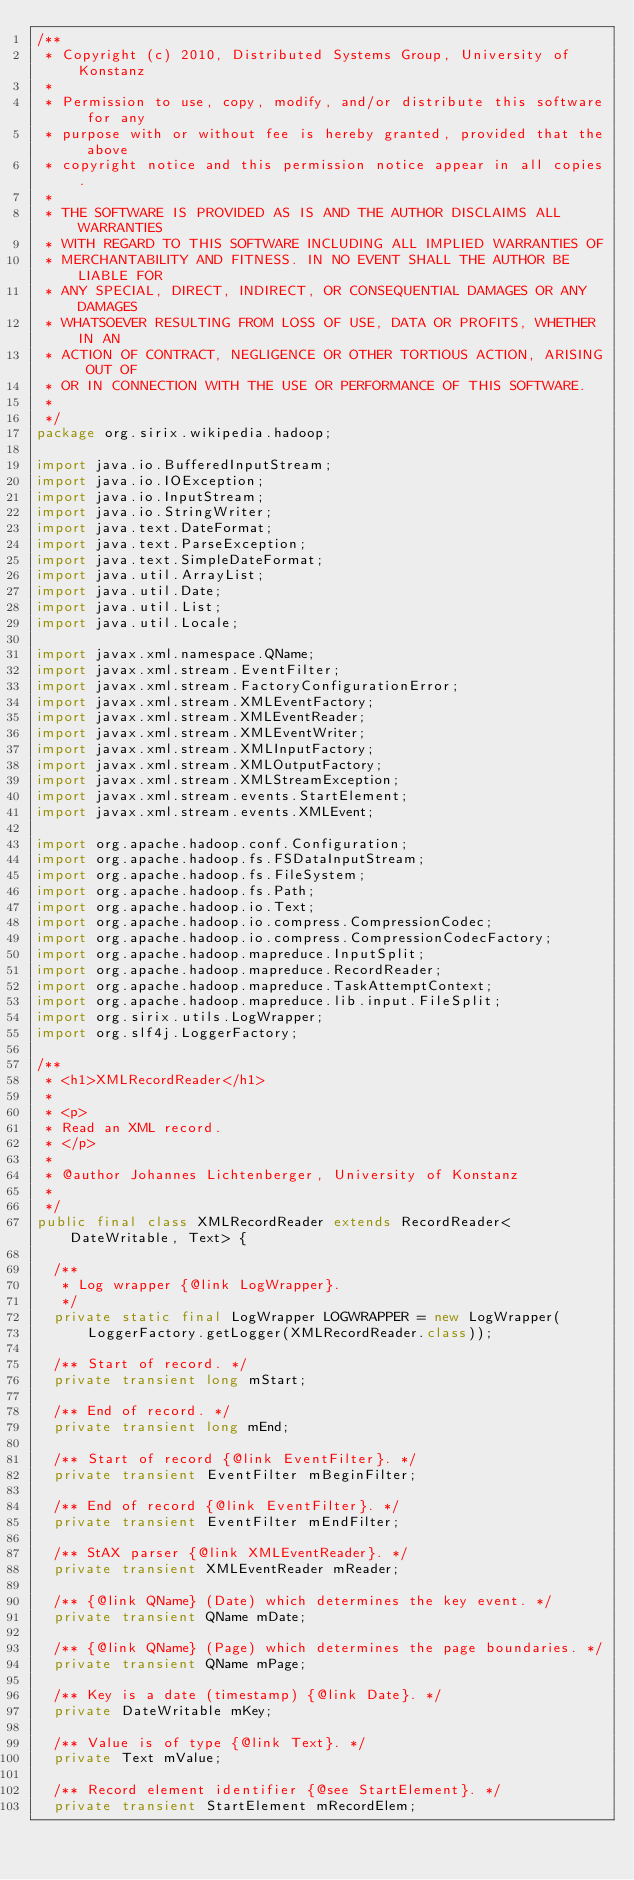<code> <loc_0><loc_0><loc_500><loc_500><_Java_>/**
 * Copyright (c) 2010, Distributed Systems Group, University of Konstanz
 * 
 * Permission to use, copy, modify, and/or distribute this software for any
 * purpose with or without fee is hereby granted, provided that the above
 * copyright notice and this permission notice appear in all copies.
 * 
 * THE SOFTWARE IS PROVIDED AS IS AND THE AUTHOR DISCLAIMS ALL WARRANTIES
 * WITH REGARD TO THIS SOFTWARE INCLUDING ALL IMPLIED WARRANTIES OF
 * MERCHANTABILITY AND FITNESS. IN NO EVENT SHALL THE AUTHOR BE LIABLE FOR
 * ANY SPECIAL, DIRECT, INDIRECT, OR CONSEQUENTIAL DAMAGES OR ANY DAMAGES
 * WHATSOEVER RESULTING FROM LOSS OF USE, DATA OR PROFITS, WHETHER IN AN
 * ACTION OF CONTRACT, NEGLIGENCE OR OTHER TORTIOUS ACTION, ARISING OUT OF
 * OR IN CONNECTION WITH THE USE OR PERFORMANCE OF THIS SOFTWARE.
 * 
 */
package org.sirix.wikipedia.hadoop;

import java.io.BufferedInputStream;
import java.io.IOException;
import java.io.InputStream;
import java.io.StringWriter;
import java.text.DateFormat;
import java.text.ParseException;
import java.text.SimpleDateFormat;
import java.util.ArrayList;
import java.util.Date;
import java.util.List;
import java.util.Locale;

import javax.xml.namespace.QName;
import javax.xml.stream.EventFilter;
import javax.xml.stream.FactoryConfigurationError;
import javax.xml.stream.XMLEventFactory;
import javax.xml.stream.XMLEventReader;
import javax.xml.stream.XMLEventWriter;
import javax.xml.stream.XMLInputFactory;
import javax.xml.stream.XMLOutputFactory;
import javax.xml.stream.XMLStreamException;
import javax.xml.stream.events.StartElement;
import javax.xml.stream.events.XMLEvent;

import org.apache.hadoop.conf.Configuration;
import org.apache.hadoop.fs.FSDataInputStream;
import org.apache.hadoop.fs.FileSystem;
import org.apache.hadoop.fs.Path;
import org.apache.hadoop.io.Text;
import org.apache.hadoop.io.compress.CompressionCodec;
import org.apache.hadoop.io.compress.CompressionCodecFactory;
import org.apache.hadoop.mapreduce.InputSplit;
import org.apache.hadoop.mapreduce.RecordReader;
import org.apache.hadoop.mapreduce.TaskAttemptContext;
import org.apache.hadoop.mapreduce.lib.input.FileSplit;
import org.sirix.utils.LogWrapper;
import org.slf4j.LoggerFactory;

/**
 * <h1>XMLRecordReader</h1>
 * 
 * <p>
 * Read an XML record.
 * </p>
 * 
 * @author Johannes Lichtenberger, University of Konstanz
 * 
 */
public final class XMLRecordReader extends RecordReader<DateWritable, Text> {

	/**
	 * Log wrapper {@link LogWrapper}.
	 */
	private static final LogWrapper LOGWRAPPER = new LogWrapper(
			LoggerFactory.getLogger(XMLRecordReader.class));

	/** Start of record. */
	private transient long mStart;

	/** End of record. */
	private transient long mEnd;

	/** Start of record {@link EventFilter}. */
	private transient EventFilter mBeginFilter;

	/** End of record {@link EventFilter}. */
	private transient EventFilter mEndFilter;

	/** StAX parser {@link XMLEventReader}. */
	private transient XMLEventReader mReader;

	/** {@link QName} (Date) which determines the key event. */
	private transient QName mDate;

	/** {@link QName} (Page) which determines the page boundaries. */
	private transient QName mPage;

	/** Key is a date (timestamp) {@link Date}. */
	private DateWritable mKey;

	/** Value is of type {@link Text}. */
	private Text mValue;

	/** Record element identifier {@see StartElement}. */
	private transient StartElement mRecordElem;
</code> 